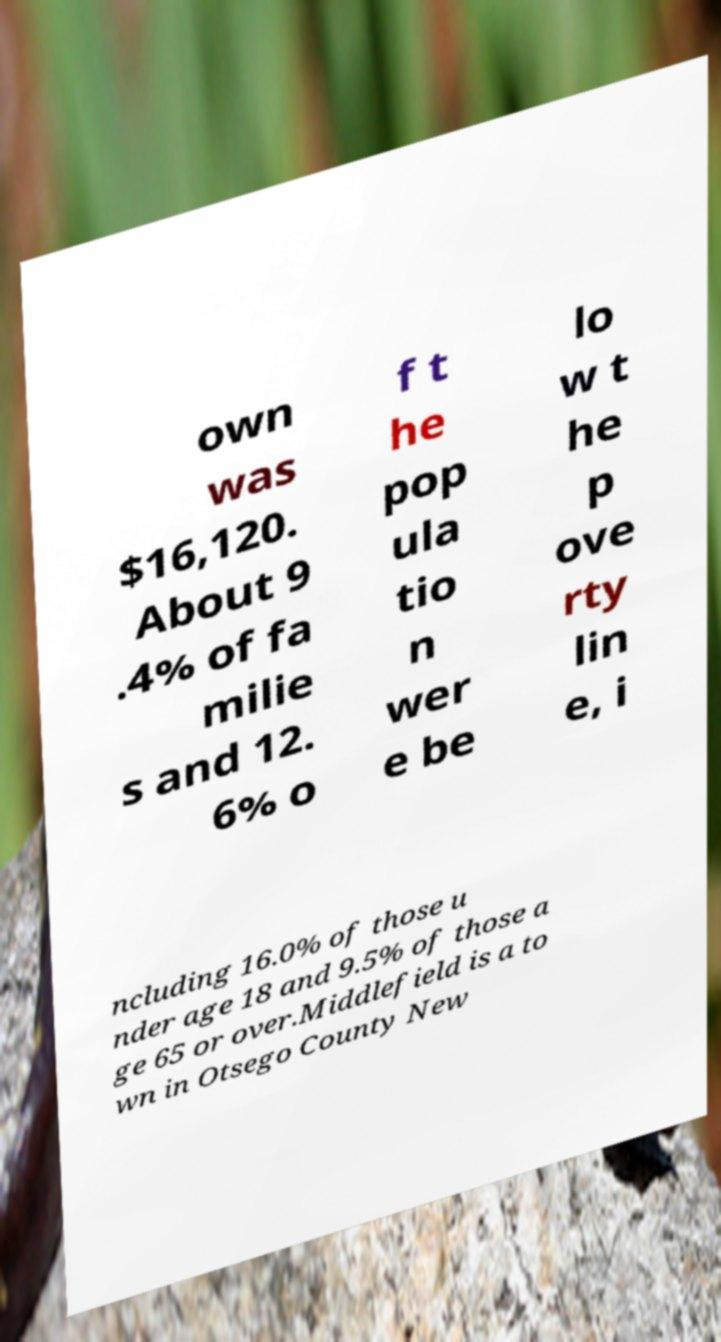Could you extract and type out the text from this image? own was $16,120. About 9 .4% of fa milie s and 12. 6% o f t he pop ula tio n wer e be lo w t he p ove rty lin e, i ncluding 16.0% of those u nder age 18 and 9.5% of those a ge 65 or over.Middlefield is a to wn in Otsego County New 